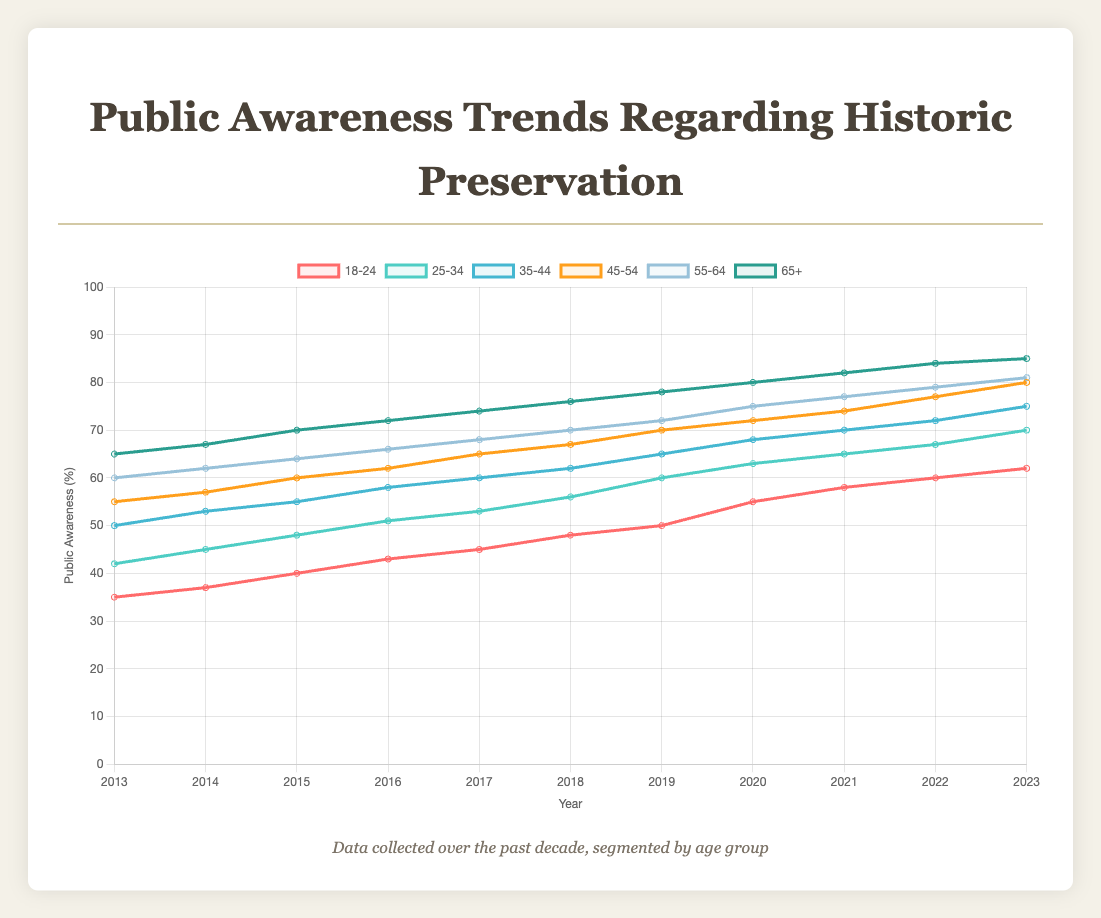Which age group has shown the highest increase in public awareness from 2013 to 2023? To find the highest increase, take the difference between the 2023 and 2013 values for each age group. 
18-24: 62 - 35 = 27,
25-34: 70 - 42 = 28,
35-44: 75 - 50 = 25,
45-54: 80 - 55 = 25,
55-64: 81 - 60 = 21,
65+: 85 - 65 = 20.
The group 25-34 has the highest increase of 28.
Answer: 25-34 In which year did the 65+ age group reach 80% public awareness? Look at the data for the 65+ group. The value reaches 80 in the year 2020.
Answer: 2020 Which age group had the lowest public awareness in 2017? Compare the public awareness values for all age groups in 2017:
18-24: 45,
25-34: 53,
35-44: 60,
45-54: 65,
55-64: 68,
65+: 74.
The 18-24 group has the lowest value of 45 in 2017.
Answer: 18-24 By how much did public awareness for the 18-24 age group increase from 2016 to 2020? Look at the values for 2016 and 2020 for the 18-24 group. The increase is 55 - 43 = 12.
Answer: 12 Which two age groups had an equal level of public awareness in 2013, and what was that level? Compare the 2013 values for all age groups:
18-24: 35,
25-34: 42,
35-44: 50,
45-54: 55,
55-64: 60,
65+: 65.
None of the groups have equal values in 2013.
Answer: None For the age group 35-44, what is the average public awareness over the entire decade? Sum the values for each year and divide by the number of years (11):
(50 + 53 + 55 + 58 + 60 + 62 + 65 + 68 + 70 + 72 + 75) / 11 = 688 / 11 ≈ 62.55.
Answer: 62.55 How does the public awareness level of the 18-24 age group in 2023 compare with that of the 45-54 age group in 2013? Compare the values:
18-24 in 2023: 62,
45-54 in 2013: 55.
62 is greater than 55.
Answer: 62 > 55 